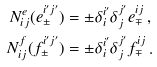Convert formula to latex. <formula><loc_0><loc_0><loc_500><loc_500>N ^ { e } _ { i j } ( e ^ { i ^ { \prime } j ^ { \prime } } _ { \pm } ) & = \pm \delta ^ { i ^ { \prime } } _ { i } \delta ^ { j ^ { \prime } } _ { j } e ^ { i j } _ { \mp } \, , \\ N ^ { f } _ { i j } ( f ^ { i ^ { \prime } j ^ { \prime } } _ { \pm } ) & = \pm \delta ^ { i ^ { \prime } } _ { i } \delta ^ { j ^ { \prime } } _ { j } f ^ { i j } _ { \mp } \, .</formula> 